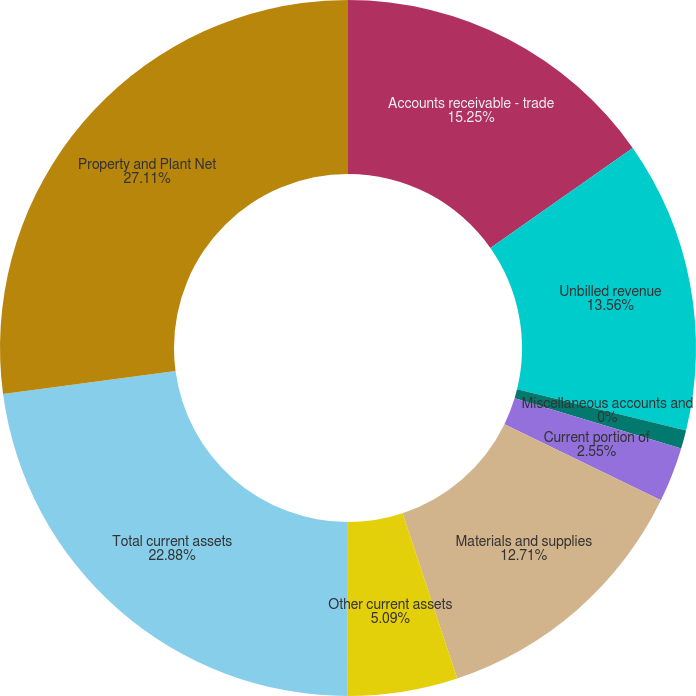<chart> <loc_0><loc_0><loc_500><loc_500><pie_chart><fcel>Accounts receivable - trade<fcel>Unbilled revenue<fcel>Miscellaneous accounts and<fcel>Accounts receivable -<fcel>Current portion of<fcel>Materials and supplies<fcel>Other current assets<fcel>Total current assets<fcel>Property and Plant Net<nl><fcel>15.25%<fcel>13.56%<fcel>0.0%<fcel>0.85%<fcel>2.55%<fcel>12.71%<fcel>5.09%<fcel>22.88%<fcel>27.11%<nl></chart> 